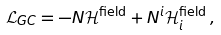<formula> <loc_0><loc_0><loc_500><loc_500>\mathcal { L } _ { G C } = - N \mathcal { H } ^ { \text {field} } + N ^ { i } \mathcal { H } ^ { \text {field} } _ { i } \, ,</formula> 